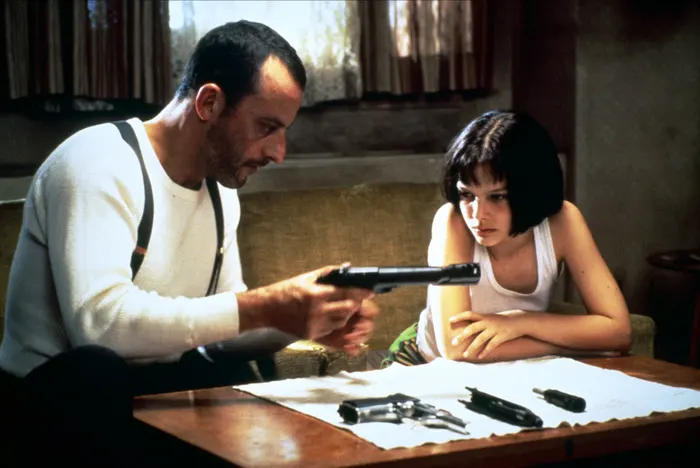Imagine if the plant in the background was central to the plot. Create a detailed story around this plant and its significance. The plant in the background, a small but vibrant green symbol, becomes a vital part of their story. This plant, given to Mathilda by her deceased younger brother, holds deep sentimental value. Before being killed by corrupt officers, Mathilda's brother hid a microchip within the plant's soil—this chip contains evidence that could dismantle an entire criminal syndicate. Unbeknownst to both Léon and Mathilda, this seemingly insignificant plant is the key to exposing the conspiracy that resulted in her brother's death. As the story unfolds, they discover the plant’s hidden treasure, setting off a thrilling quest to bring justice. Amidst the bullets and close shaves, the plant symbolizes hope, resilience, and the promise of redemption, bridging their past trauma with a future of justice. 